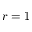Convert formula to latex. <formula><loc_0><loc_0><loc_500><loc_500>r = 1</formula> 